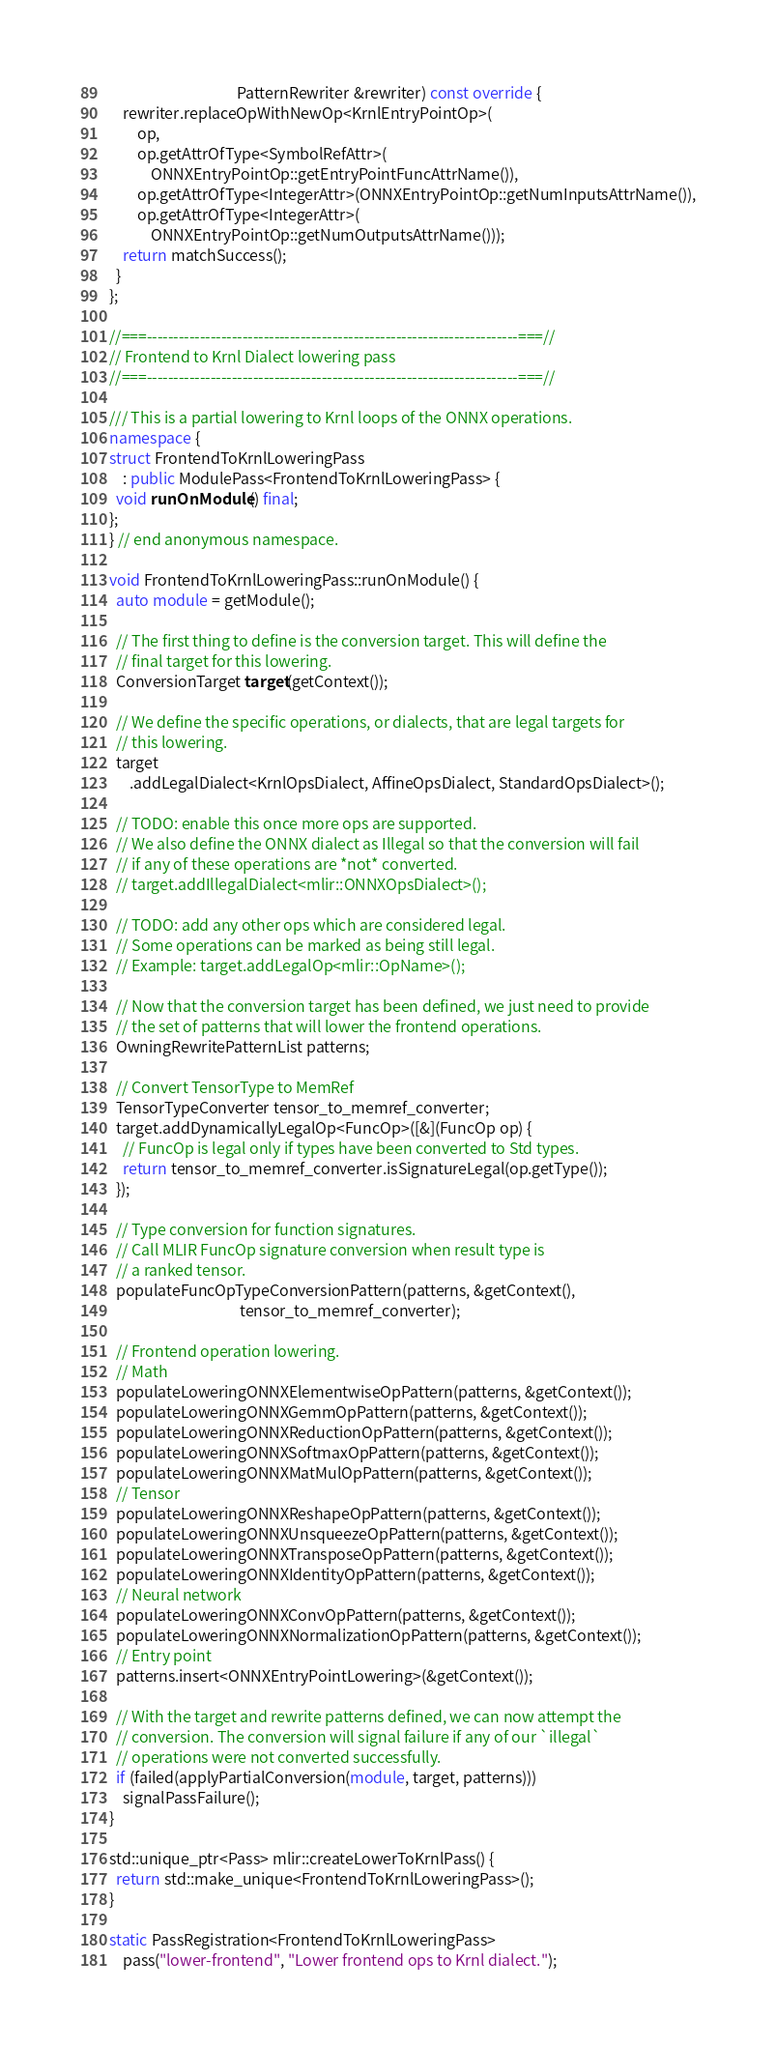Convert code to text. <code><loc_0><loc_0><loc_500><loc_500><_C++_>                                     PatternRewriter &rewriter) const override {
    rewriter.replaceOpWithNewOp<KrnlEntryPointOp>(
        op,
        op.getAttrOfType<SymbolRefAttr>(
            ONNXEntryPointOp::getEntryPointFuncAttrName()),
        op.getAttrOfType<IntegerAttr>(ONNXEntryPointOp::getNumInputsAttrName()),
        op.getAttrOfType<IntegerAttr>(
            ONNXEntryPointOp::getNumOutputsAttrName()));
    return matchSuccess();
  }
};

//===----------------------------------------------------------------------===//
// Frontend to Krnl Dialect lowering pass
//===----------------------------------------------------------------------===//

/// This is a partial lowering to Krnl loops of the ONNX operations.
namespace {
struct FrontendToKrnlLoweringPass
    : public ModulePass<FrontendToKrnlLoweringPass> {
  void runOnModule() final;
};
} // end anonymous namespace.

void FrontendToKrnlLoweringPass::runOnModule() {
  auto module = getModule();

  // The first thing to define is the conversion target. This will define the
  // final target for this lowering.
  ConversionTarget target(getContext());

  // We define the specific operations, or dialects, that are legal targets for
  // this lowering.
  target
      .addLegalDialect<KrnlOpsDialect, AffineOpsDialect, StandardOpsDialect>();

  // TODO: enable this once more ops are supported.
  // We also define the ONNX dialect as Illegal so that the conversion will fail
  // if any of these operations are *not* converted.
  // target.addIllegalDialect<mlir::ONNXOpsDialect>();

  // TODO: add any other ops which are considered legal.
  // Some operations can be marked as being still legal.
  // Example: target.addLegalOp<mlir::OpName>();

  // Now that the conversion target has been defined, we just need to provide
  // the set of patterns that will lower the frontend operations.
  OwningRewritePatternList patterns;

  // Convert TensorType to MemRef
  TensorTypeConverter tensor_to_memref_converter;
  target.addDynamicallyLegalOp<FuncOp>([&](FuncOp op) {
    // FuncOp is legal only if types have been converted to Std types.
    return tensor_to_memref_converter.isSignatureLegal(op.getType());
  });

  // Type conversion for function signatures.
  // Call MLIR FuncOp signature conversion when result type is
  // a ranked tensor.
  populateFuncOpTypeConversionPattern(patterns, &getContext(),
                                      tensor_to_memref_converter);

  // Frontend operation lowering.
  // Math
  populateLoweringONNXElementwiseOpPattern(patterns, &getContext());
  populateLoweringONNXGemmOpPattern(patterns, &getContext());
  populateLoweringONNXReductionOpPattern(patterns, &getContext());
  populateLoweringONNXSoftmaxOpPattern(patterns, &getContext());
  populateLoweringONNXMatMulOpPattern(patterns, &getContext());
  // Tensor
  populateLoweringONNXReshapeOpPattern(patterns, &getContext());
  populateLoweringONNXUnsqueezeOpPattern(patterns, &getContext());
  populateLoweringONNXTransposeOpPattern(patterns, &getContext());
  populateLoweringONNXIdentityOpPattern(patterns, &getContext());
  // Neural network
  populateLoweringONNXConvOpPattern(patterns, &getContext());
  populateLoweringONNXNormalizationOpPattern(patterns, &getContext());
  // Entry point
  patterns.insert<ONNXEntryPointLowering>(&getContext());

  // With the target and rewrite patterns defined, we can now attempt the
  // conversion. The conversion will signal failure if any of our `illegal`
  // operations were not converted successfully.
  if (failed(applyPartialConversion(module, target, patterns)))
    signalPassFailure();
}

std::unique_ptr<Pass> mlir::createLowerToKrnlPass() {
  return std::make_unique<FrontendToKrnlLoweringPass>();
}

static PassRegistration<FrontendToKrnlLoweringPass>
    pass("lower-frontend", "Lower frontend ops to Krnl dialect.");
</code> 